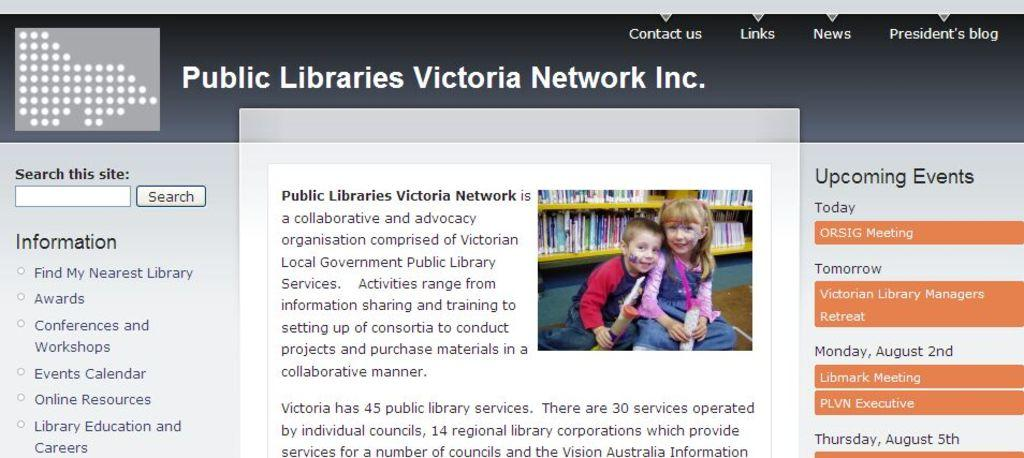What type of content is displayed in the image? The image appears to be a website page. What can be found on the website page? There is text and an image of kids on the website page. What type of temper does the locket have in the image? There is no locket present in the image, so it is not possible to determine its temper. 